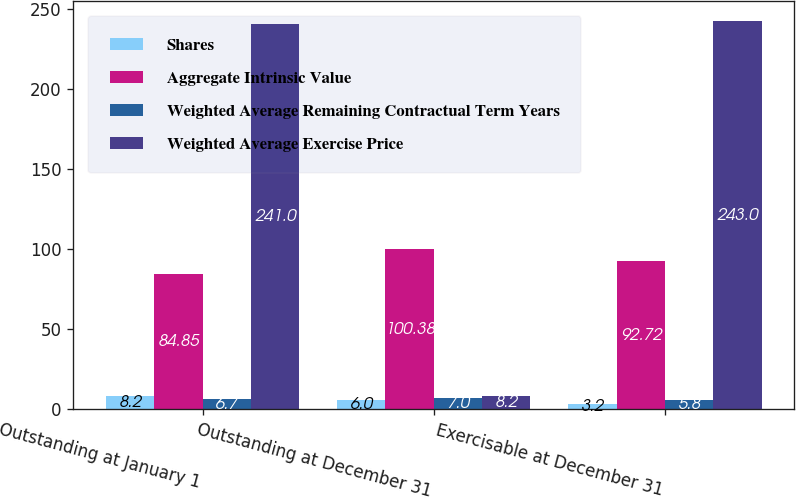Convert chart. <chart><loc_0><loc_0><loc_500><loc_500><stacked_bar_chart><ecel><fcel>Outstanding at January 1<fcel>Outstanding at December 31<fcel>Exercisable at December 31<nl><fcel>Shares<fcel>8.2<fcel>6<fcel>3.2<nl><fcel>Aggregate Intrinsic Value<fcel>84.85<fcel>100.38<fcel>92.72<nl><fcel>Weighted Average Remaining Contractual Term Years<fcel>6.7<fcel>7<fcel>5.8<nl><fcel>Weighted Average Exercise Price<fcel>241<fcel>8.2<fcel>243<nl></chart> 